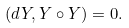Convert formula to latex. <formula><loc_0><loc_0><loc_500><loc_500>( d Y , Y \circ Y ) = 0 .</formula> 